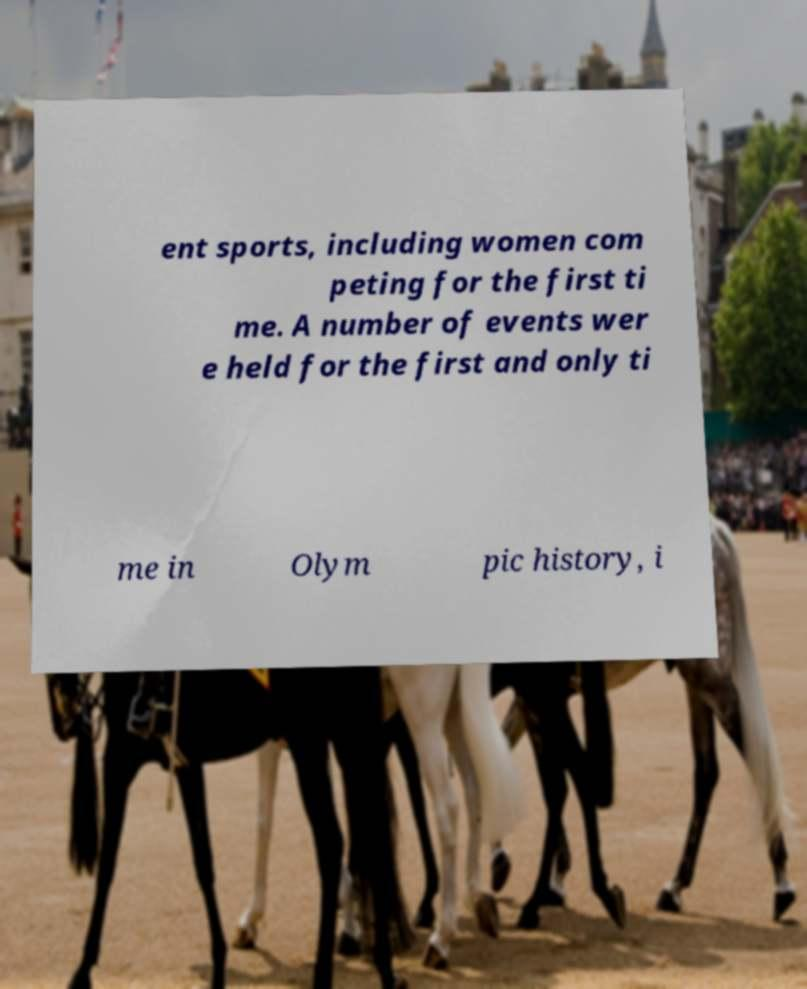Could you extract and type out the text from this image? ent sports, including women com peting for the first ti me. A number of events wer e held for the first and only ti me in Olym pic history, i 